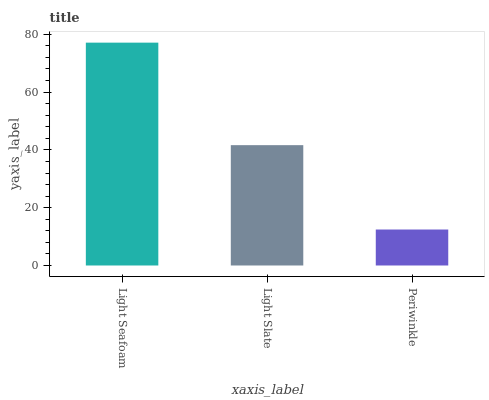Is Periwinkle the minimum?
Answer yes or no. Yes. Is Light Seafoam the maximum?
Answer yes or no. Yes. Is Light Slate the minimum?
Answer yes or no. No. Is Light Slate the maximum?
Answer yes or no. No. Is Light Seafoam greater than Light Slate?
Answer yes or no. Yes. Is Light Slate less than Light Seafoam?
Answer yes or no. Yes. Is Light Slate greater than Light Seafoam?
Answer yes or no. No. Is Light Seafoam less than Light Slate?
Answer yes or no. No. Is Light Slate the high median?
Answer yes or no. Yes. Is Light Slate the low median?
Answer yes or no. Yes. Is Light Seafoam the high median?
Answer yes or no. No. Is Periwinkle the low median?
Answer yes or no. No. 